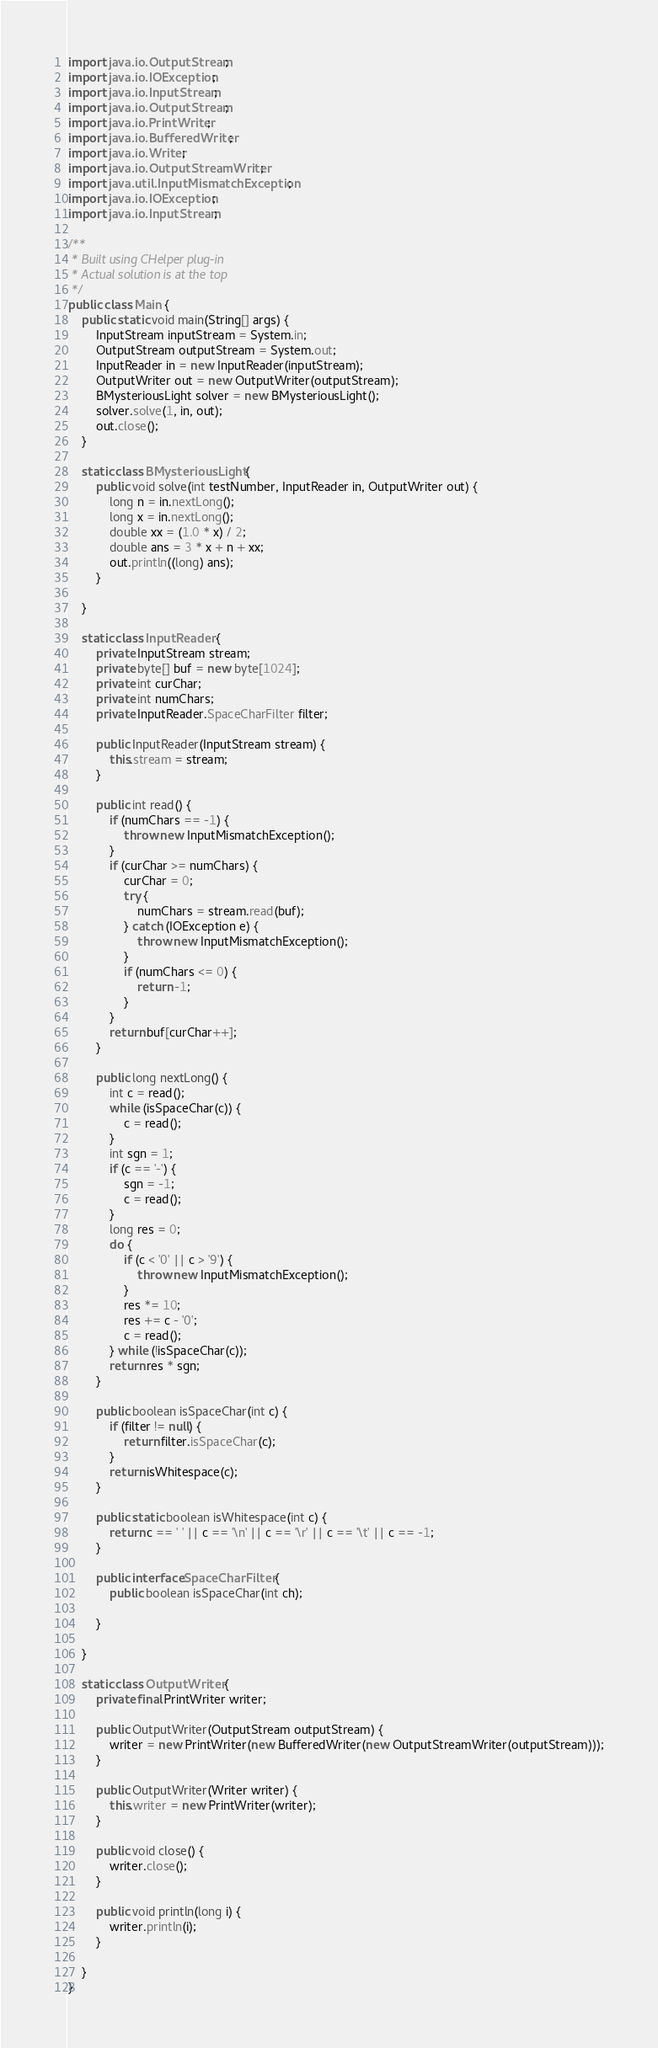<code> <loc_0><loc_0><loc_500><loc_500><_Java_>import java.io.OutputStream;
import java.io.IOException;
import java.io.InputStream;
import java.io.OutputStream;
import java.io.PrintWriter;
import java.io.BufferedWriter;
import java.io.Writer;
import java.io.OutputStreamWriter;
import java.util.InputMismatchException;
import java.io.IOException;
import java.io.InputStream;

/**
 * Built using CHelper plug-in
 * Actual solution is at the top
 */
public class Main {
    public static void main(String[] args) {
        InputStream inputStream = System.in;
        OutputStream outputStream = System.out;
        InputReader in = new InputReader(inputStream);
        OutputWriter out = new OutputWriter(outputStream);
        BMysteriousLight solver = new BMysteriousLight();
        solver.solve(1, in, out);
        out.close();
    }

    static class BMysteriousLight {
        public void solve(int testNumber, InputReader in, OutputWriter out) {
            long n = in.nextLong();
            long x = in.nextLong();
            double xx = (1.0 * x) / 2;
            double ans = 3 * x + n + xx;
            out.println((long) ans);
        }

    }

    static class InputReader {
        private InputStream stream;
        private byte[] buf = new byte[1024];
        private int curChar;
        private int numChars;
        private InputReader.SpaceCharFilter filter;

        public InputReader(InputStream stream) {
            this.stream = stream;
        }

        public int read() {
            if (numChars == -1) {
                throw new InputMismatchException();
            }
            if (curChar >= numChars) {
                curChar = 0;
                try {
                    numChars = stream.read(buf);
                } catch (IOException e) {
                    throw new InputMismatchException();
                }
                if (numChars <= 0) {
                    return -1;
                }
            }
            return buf[curChar++];
        }

        public long nextLong() {
            int c = read();
            while (isSpaceChar(c)) {
                c = read();
            }
            int sgn = 1;
            if (c == '-') {
                sgn = -1;
                c = read();
            }
            long res = 0;
            do {
                if (c < '0' || c > '9') {
                    throw new InputMismatchException();
                }
                res *= 10;
                res += c - '0';
                c = read();
            } while (!isSpaceChar(c));
            return res * sgn;
        }

        public boolean isSpaceChar(int c) {
            if (filter != null) {
                return filter.isSpaceChar(c);
            }
            return isWhitespace(c);
        }

        public static boolean isWhitespace(int c) {
            return c == ' ' || c == '\n' || c == '\r' || c == '\t' || c == -1;
        }

        public interface SpaceCharFilter {
            public boolean isSpaceChar(int ch);

        }

    }

    static class OutputWriter {
        private final PrintWriter writer;

        public OutputWriter(OutputStream outputStream) {
            writer = new PrintWriter(new BufferedWriter(new OutputStreamWriter(outputStream)));
        }

        public OutputWriter(Writer writer) {
            this.writer = new PrintWriter(writer);
        }

        public void close() {
            writer.close();
        }

        public void println(long i) {
            writer.println(i);
        }

    }
}

</code> 